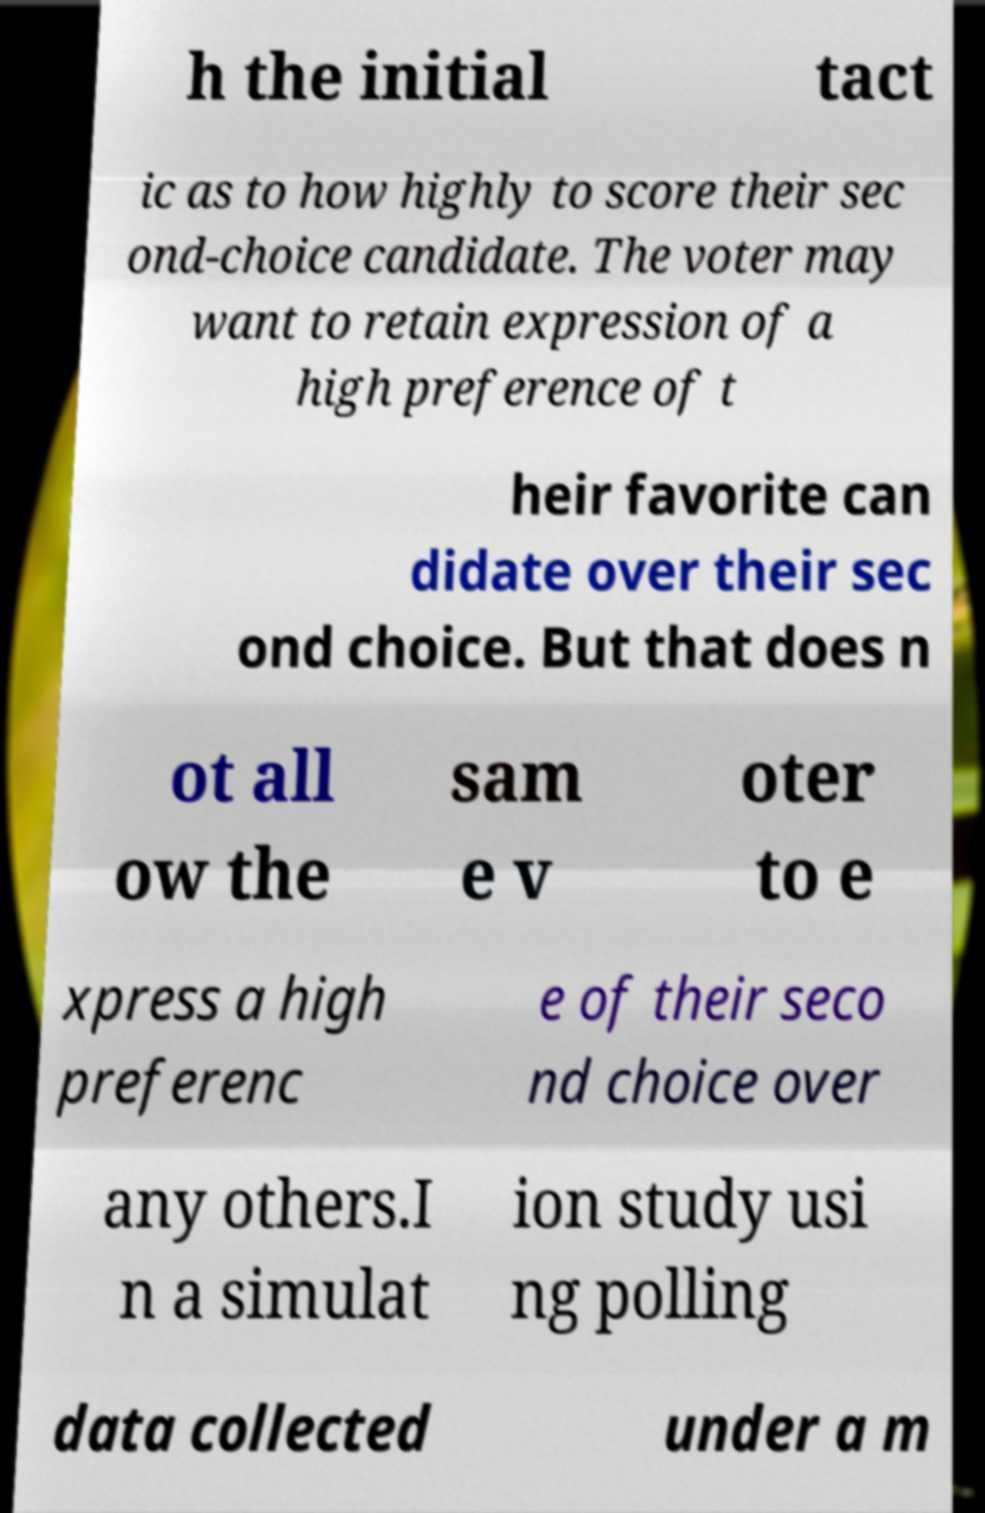Could you assist in decoding the text presented in this image and type it out clearly? h the initial tact ic as to how highly to score their sec ond-choice candidate. The voter may want to retain expression of a high preference of t heir favorite can didate over their sec ond choice. But that does n ot all ow the sam e v oter to e xpress a high preferenc e of their seco nd choice over any others.I n a simulat ion study usi ng polling data collected under a m 